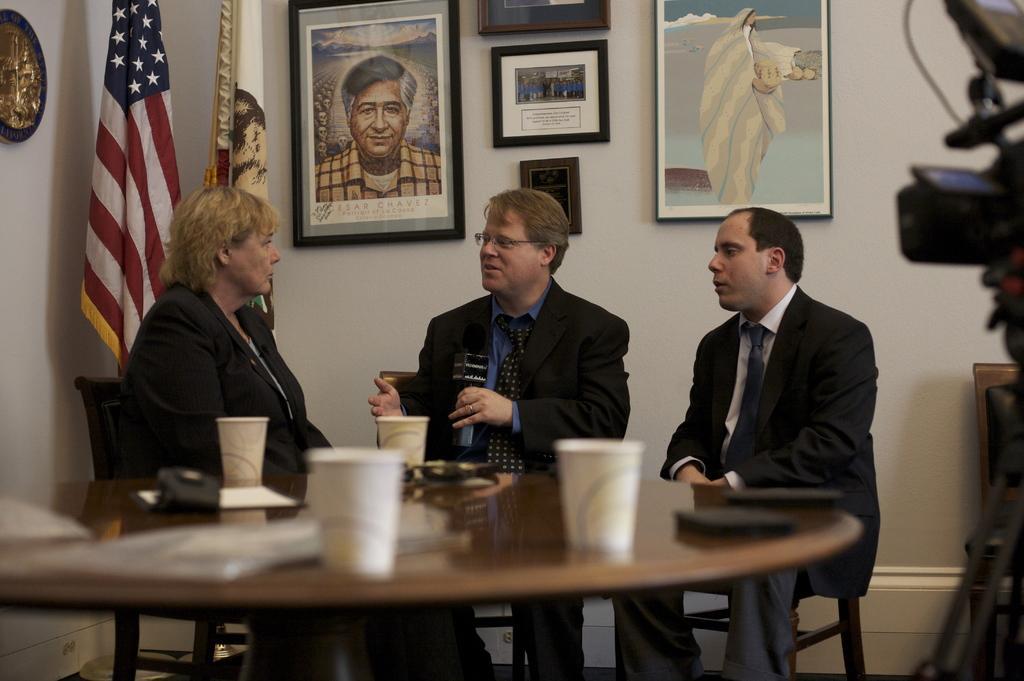In one or two sentences, can you explain what this image depicts? In this image there are three persons sitting behind the table, the person with the blue shirt is holding a microphone and he is talking. There are caps, papers and devices on the table. At the right side of the image there is a camera and at the left side of the image there is a flag and at the back there are photo frames on the wall. 